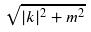Convert formula to latex. <formula><loc_0><loc_0><loc_500><loc_500>\sqrt { | k | ^ { 2 } + m ^ { 2 } }</formula> 